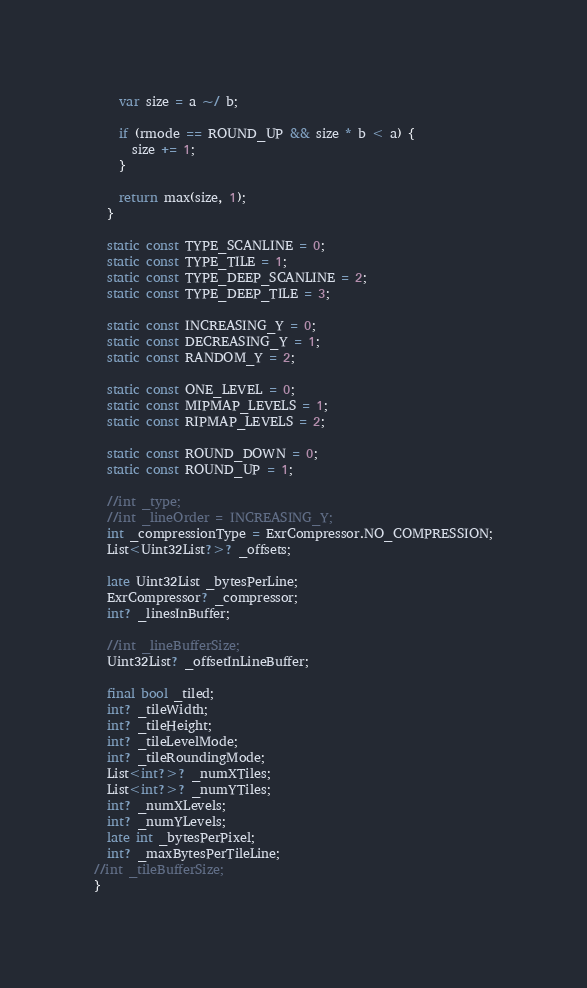<code> <loc_0><loc_0><loc_500><loc_500><_Dart_>    var size = a ~/ b;

    if (rmode == ROUND_UP && size * b < a) {
      size += 1;
    }

    return max(size, 1);
  }

  static const TYPE_SCANLINE = 0;
  static const TYPE_TILE = 1;
  static const TYPE_DEEP_SCANLINE = 2;
  static const TYPE_DEEP_TILE = 3;

  static const INCREASING_Y = 0;
  static const DECREASING_Y = 1;
  static const RANDOM_Y = 2;

  static const ONE_LEVEL = 0;
  static const MIPMAP_LEVELS = 1;
  static const RIPMAP_LEVELS = 2;

  static const ROUND_DOWN = 0;
  static const ROUND_UP = 1;

  //int _type;
  //int _lineOrder = INCREASING_Y;
  int _compressionType = ExrCompressor.NO_COMPRESSION;
  List<Uint32List?>? _offsets;

  late Uint32List _bytesPerLine;
  ExrCompressor? _compressor;
  int? _linesInBuffer;

  //int _lineBufferSize;
  Uint32List? _offsetInLineBuffer;

  final bool _tiled;
  int? _tileWidth;
  int? _tileHeight;
  int? _tileLevelMode;
  int? _tileRoundingMode;
  List<int?>? _numXTiles;
  List<int?>? _numYTiles;
  int? _numXLevels;
  int? _numYLevels;
  late int _bytesPerPixel;
  int? _maxBytesPerTileLine;
//int _tileBufferSize;
}
</code> 